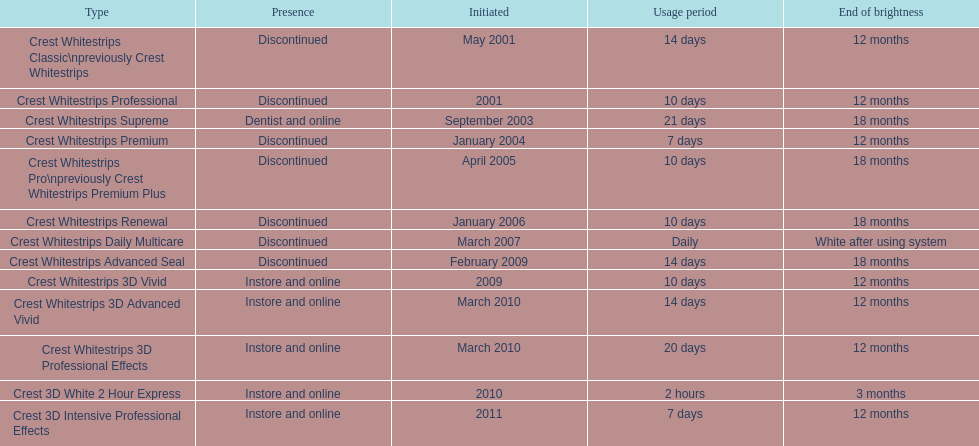Crest 3d intensive professional effects and crest whitestrips 3d professional effects both have a lasting whiteness of how many months? 12 months. 